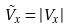Convert formula to latex. <formula><loc_0><loc_0><loc_500><loc_500>\tilde { V } _ { x } = | V _ { x } |</formula> 